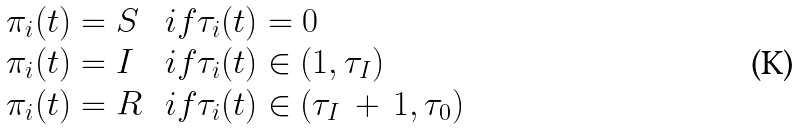Convert formula to latex. <formula><loc_0><loc_0><loc_500><loc_500>\begin{array} { l l } \pi _ { i } ( t ) = S & \, i f \tau _ { i } ( t ) = 0 \\ \pi _ { i } ( t ) = I & \, i f \tau _ { i } ( t ) \in ( 1 , \tau _ { I } ) \\ \pi _ { i } ( t ) = R & \, i f \tau _ { i } ( t ) \in ( \tau _ { I } \, + \, 1 , \tau _ { 0 } ) \end{array}</formula> 